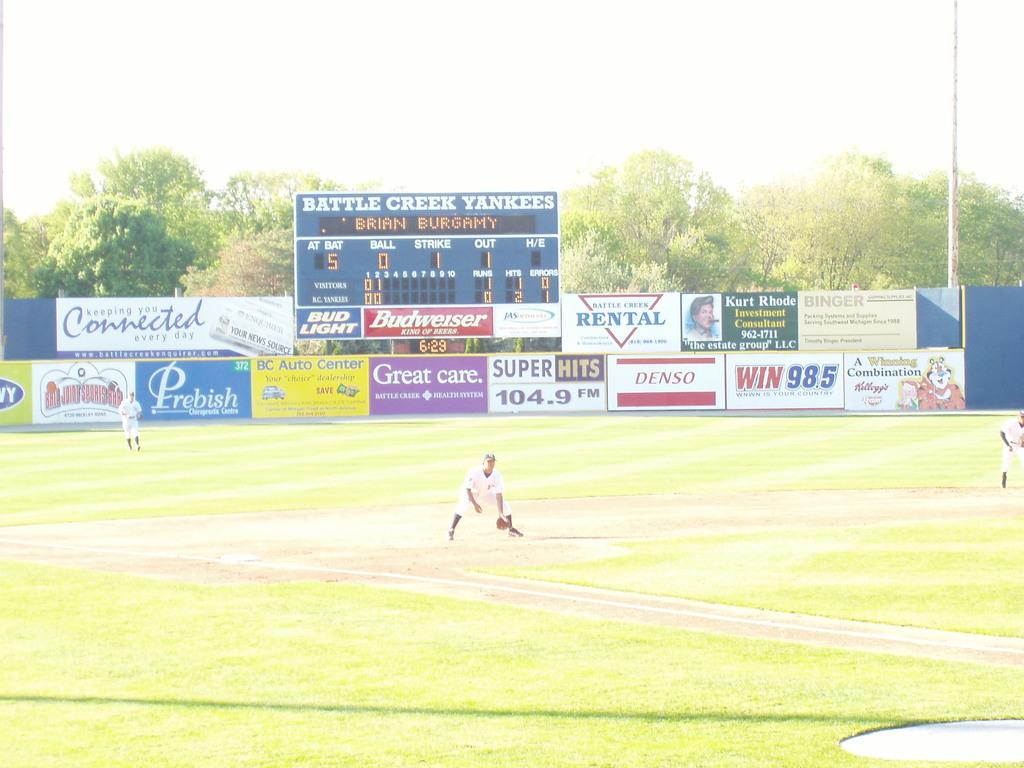What does the sign in purple say?
Give a very brief answer. Great care. What is the team name for the field?
Keep it short and to the point. Battle creek yankees. 